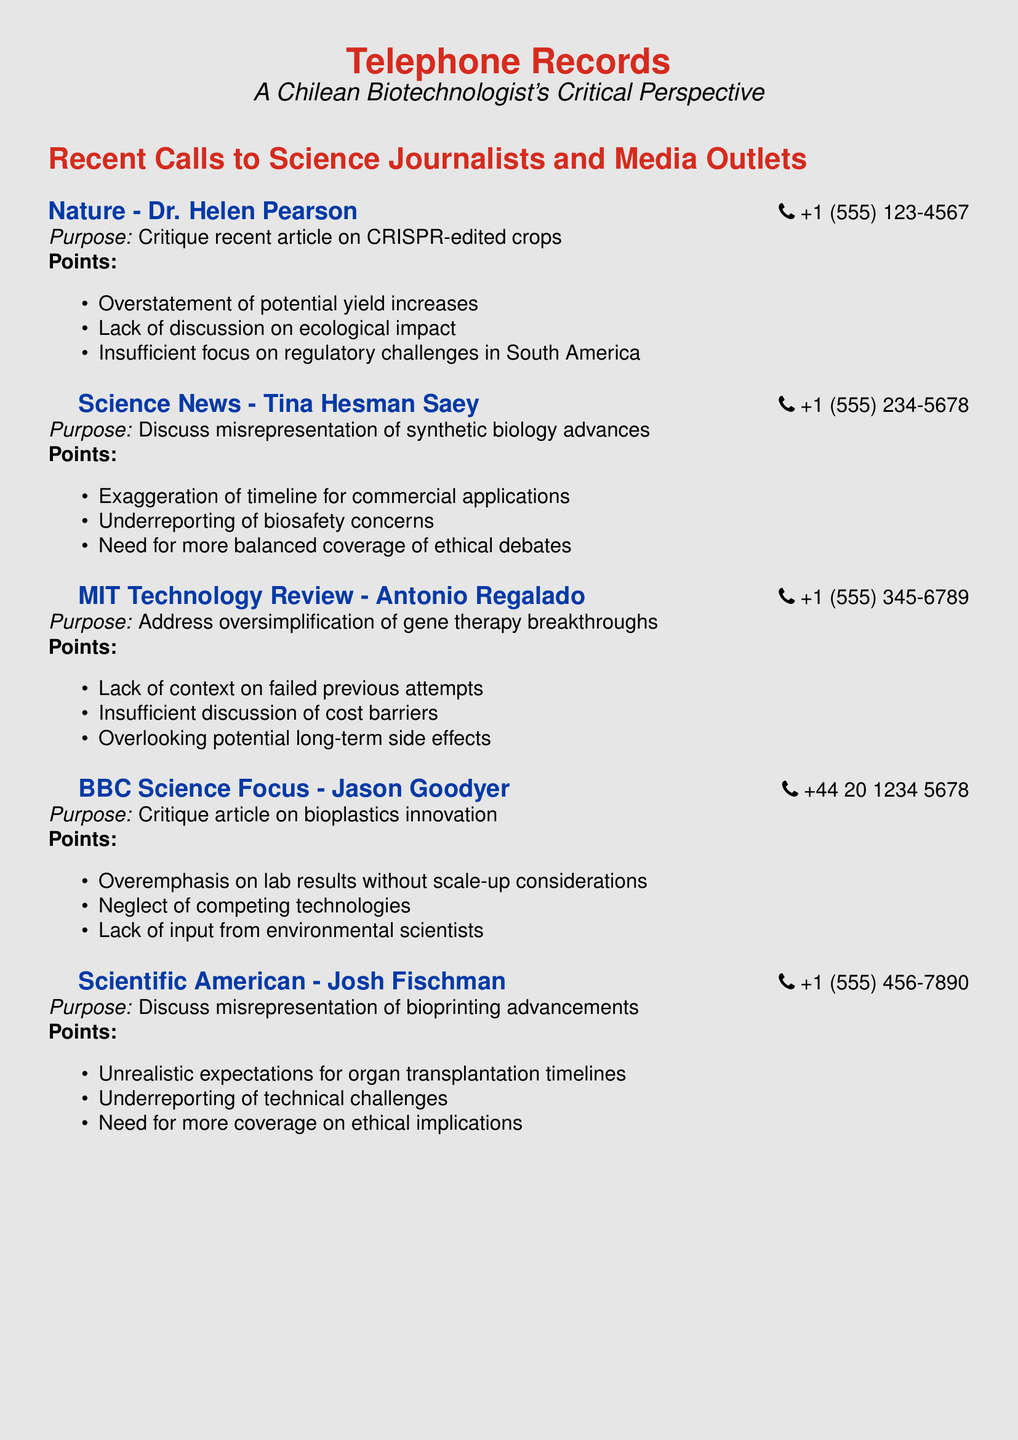What is the name of the first journalist contacted? The document lists Dr. Helen Pearson as the first journalist contacted.
Answer: Dr. Helen Pearson What is the phone number for Science News? The phone number for Science News, as listed in the document, is +1 (555) 234-5678.
Answer: +1 (555) 234-5678 What was discussed with MIT Technology Review? The discussion with MIT Technology Review involved addressing oversimplification of gene therapy breakthroughs.
Answer: Address oversimplification of gene therapy breakthroughs Which media outlet was critiqued for its article on bioplastics innovation? The media outlet critiqued for its article on bioplastics innovation is BBC Science Focus.
Answer: BBC Science Focus How many points were raised in the call to Scientific American? There are three points raised in the call to Scientific American.
Answer: 3 What is the purpose of the call to Nature? The purpose of the call to Nature was a critique of a recent article on CRISPR-edited crops.
Answer: Critique recent article on CRISPR-edited crops Which publication highlighted ethical debates related to synthetic biology? Science News highlighted ethical debates related to synthetic biology.
Answer: Science News What was the primary critique raised in the call to BBC Science Focus? The primary critique raised was regarding the overemphasis on lab results without scale-up considerations.
Answer: Overemphasis on lab results without scale-up considerations 